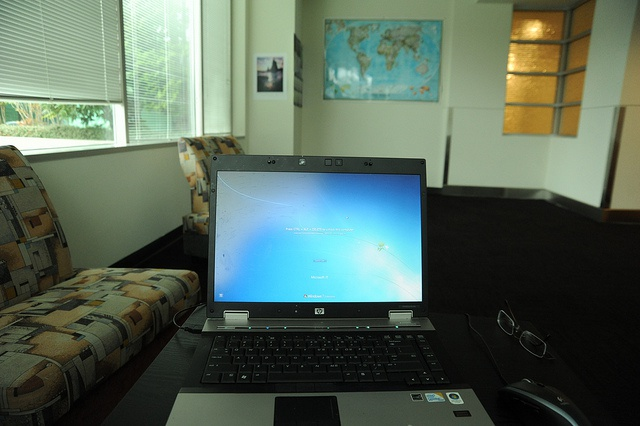Describe the objects in this image and their specific colors. I can see laptop in gray, black, and lightblue tones, couch in gray, black, and darkgreen tones, chair in gray, black, darkgreen, and olive tones, and mouse in gray, black, and teal tones in this image. 